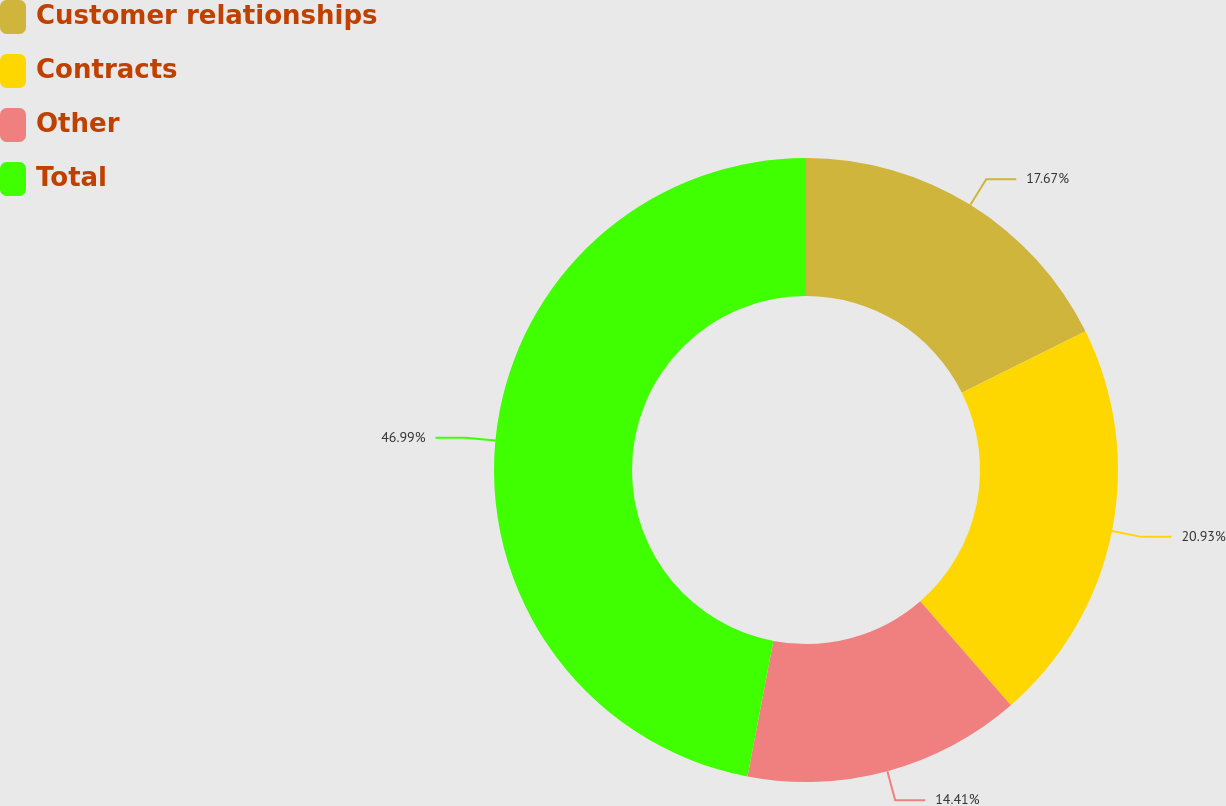<chart> <loc_0><loc_0><loc_500><loc_500><pie_chart><fcel>Customer relationships<fcel>Contracts<fcel>Other<fcel>Total<nl><fcel>17.67%<fcel>20.93%<fcel>14.41%<fcel>47.0%<nl></chart> 